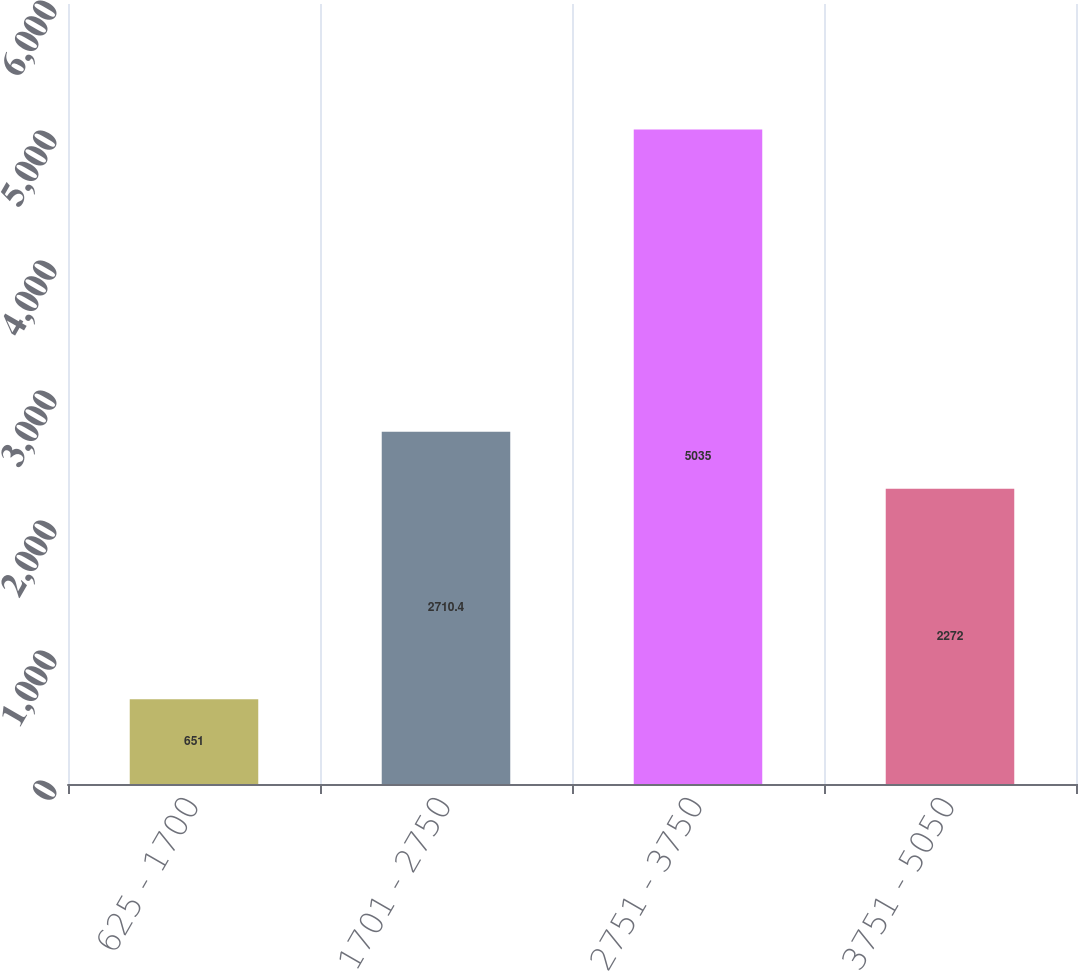<chart> <loc_0><loc_0><loc_500><loc_500><bar_chart><fcel>625 - 1700<fcel>1701 - 2750<fcel>2751 - 3750<fcel>3751 - 5050<nl><fcel>651<fcel>2710.4<fcel>5035<fcel>2272<nl></chart> 